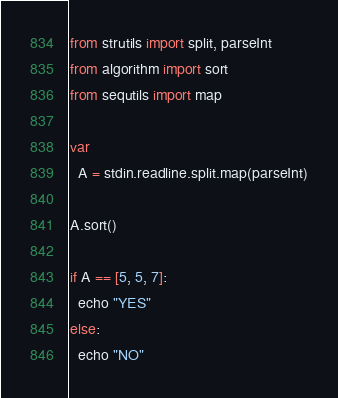<code> <loc_0><loc_0><loc_500><loc_500><_Nim_>from strutils import split, parseInt
from algorithm import sort
from sequtils import map

var
  A = stdin.readline.split.map(parseInt)

A.sort()

if A == [5, 5, 7]:
  echo "YES"
else:
  echo "NO"
</code> 